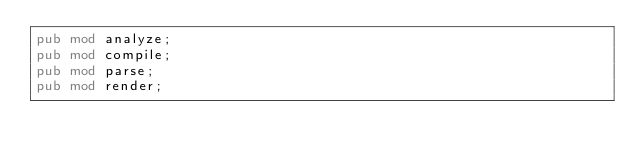<code> <loc_0><loc_0><loc_500><loc_500><_Rust_>pub mod analyze;
pub mod compile;
pub mod parse;
pub mod render;
</code> 